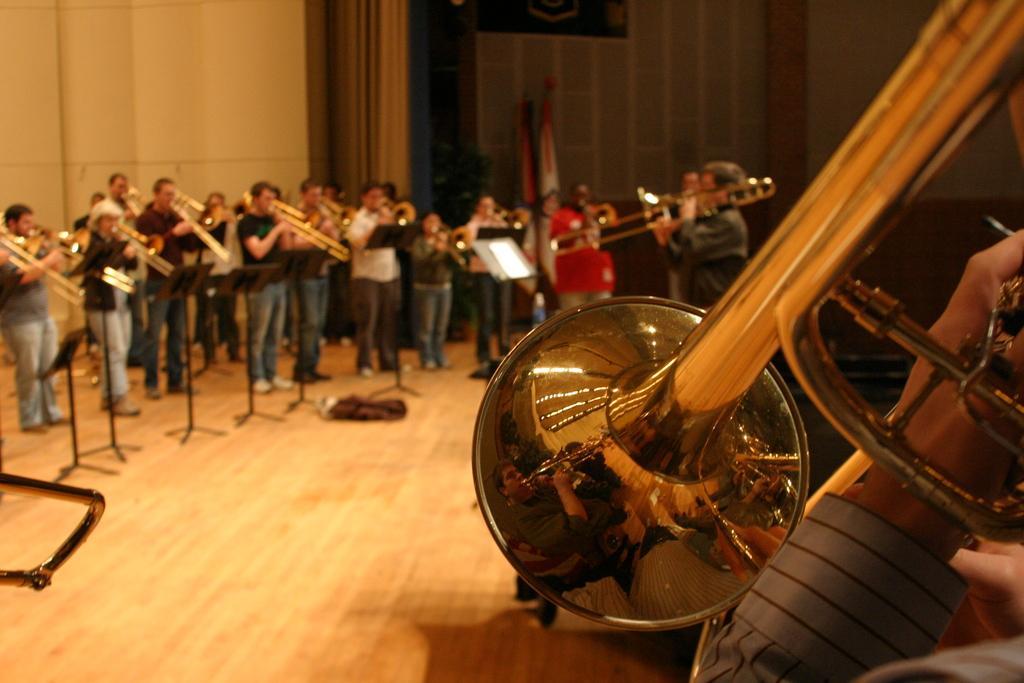In one or two sentences, can you explain what this image depicts? In this image we can see a few people playing musical instruments, there are some stands, papers, also we can see the wall, and curtains. 